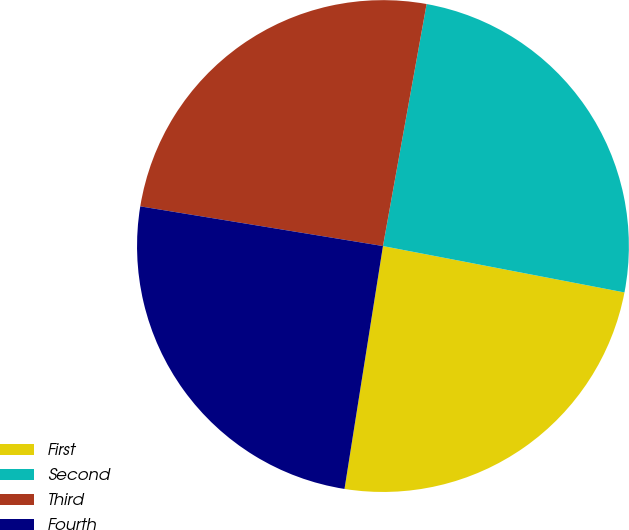Convert chart. <chart><loc_0><loc_0><loc_500><loc_500><pie_chart><fcel>First<fcel>Second<fcel>Third<fcel>Fourth<nl><fcel>24.48%<fcel>25.18%<fcel>25.26%<fcel>25.08%<nl></chart> 